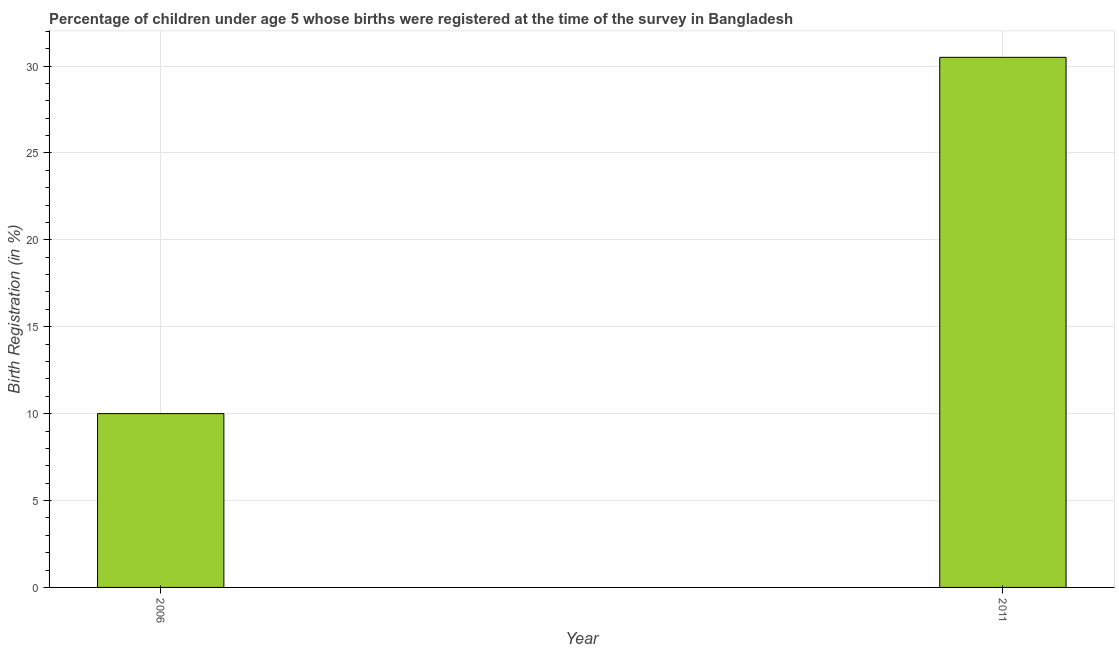Does the graph contain any zero values?
Ensure brevity in your answer.  No. What is the title of the graph?
Make the answer very short. Percentage of children under age 5 whose births were registered at the time of the survey in Bangladesh. What is the label or title of the X-axis?
Provide a succinct answer. Year. What is the label or title of the Y-axis?
Your answer should be compact. Birth Registration (in %). What is the birth registration in 2006?
Your answer should be very brief. 10. Across all years, what is the maximum birth registration?
Offer a terse response. 30.5. In which year was the birth registration maximum?
Provide a short and direct response. 2011. What is the sum of the birth registration?
Provide a succinct answer. 40.5. What is the difference between the birth registration in 2006 and 2011?
Offer a terse response. -20.5. What is the average birth registration per year?
Your response must be concise. 20.25. What is the median birth registration?
Give a very brief answer. 20.25. In how many years, is the birth registration greater than 3 %?
Your answer should be very brief. 2. What is the ratio of the birth registration in 2006 to that in 2011?
Give a very brief answer. 0.33. Is the birth registration in 2006 less than that in 2011?
Offer a very short reply. Yes. How many bars are there?
Your answer should be compact. 2. How many years are there in the graph?
Provide a short and direct response. 2. What is the difference between two consecutive major ticks on the Y-axis?
Offer a terse response. 5. What is the Birth Registration (in %) in 2011?
Make the answer very short. 30.5. What is the difference between the Birth Registration (in %) in 2006 and 2011?
Give a very brief answer. -20.5. What is the ratio of the Birth Registration (in %) in 2006 to that in 2011?
Provide a short and direct response. 0.33. 